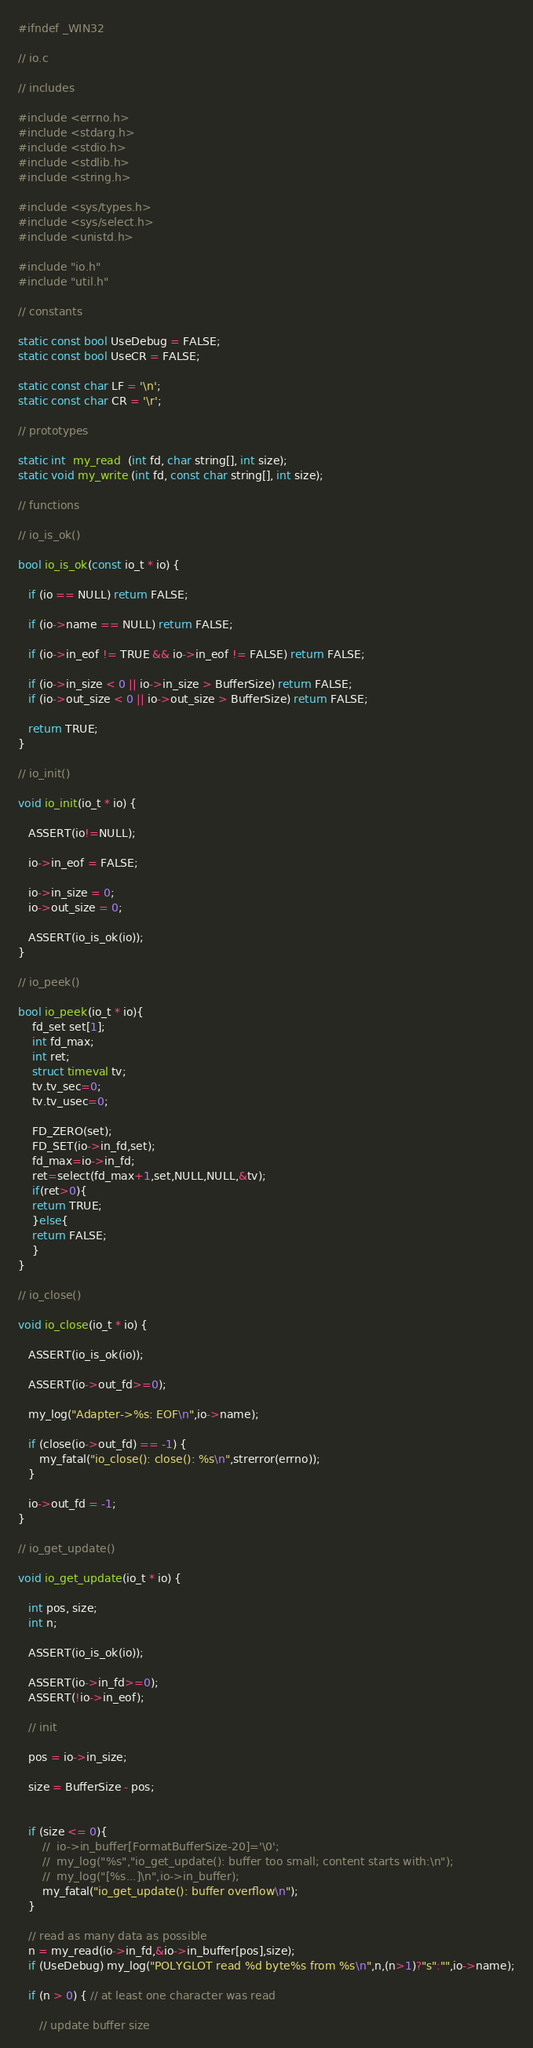Convert code to text. <code><loc_0><loc_0><loc_500><loc_500><_C_>#ifndef _WIN32

// io.c

// includes

#include <errno.h>
#include <stdarg.h>
#include <stdio.h>
#include <stdlib.h>
#include <string.h>

#include <sys/types.h>
#include <sys/select.h>
#include <unistd.h>

#include "io.h"
#include "util.h"

// constants

static const bool UseDebug = FALSE;
static const bool UseCR = FALSE;

static const char LF = '\n';
static const char CR = '\r';

// prototypes

static int  my_read  (int fd, char string[], int size);
static void my_write (int fd, const char string[], int size);

// functions

// io_is_ok()

bool io_is_ok(const io_t * io) {

   if (io == NULL) return FALSE;

   if (io->name == NULL) return FALSE;

   if (io->in_eof != TRUE && io->in_eof != FALSE) return FALSE;

   if (io->in_size < 0 || io->in_size > BufferSize) return FALSE;
   if (io->out_size < 0 || io->out_size > BufferSize) return FALSE;

   return TRUE;
}

// io_init()

void io_init(io_t * io) {

   ASSERT(io!=NULL);

   io->in_eof = FALSE;

   io->in_size = 0;
   io->out_size = 0;

   ASSERT(io_is_ok(io));
}

// io_peek()

bool io_peek(io_t * io){
    fd_set set[1];
    int fd_max;
    int ret;
    struct timeval tv;
    tv.tv_sec=0;
    tv.tv_usec=0;
  
    FD_ZERO(set);
    FD_SET(io->in_fd,set);
    fd_max=io->in_fd;
    ret=select(fd_max+1,set,NULL,NULL,&tv);
    if(ret>0){
	return TRUE;
    }else{
	return FALSE;
    }
}

// io_close()

void io_close(io_t * io) {

   ASSERT(io_is_ok(io));

   ASSERT(io->out_fd>=0);

   my_log("Adapter->%s: EOF\n",io->name);

   if (close(io->out_fd) == -1) {
      my_fatal("io_close(): close(): %s\n",strerror(errno));
   }

   io->out_fd = -1;
}

// io_get_update()

void io_get_update(io_t * io) {

   int pos, size;
   int n;

   ASSERT(io_is_ok(io));

   ASSERT(io->in_fd>=0);
   ASSERT(!io->in_eof);

   // init

   pos = io->in_size;

   size = BufferSize - pos;


   if (size <= 0){
       //  io->in_buffer[FormatBufferSize-20]='\0';
       //  my_log("%s","io_get_update(): buffer too small; content starts with:\n");
       //  my_log("[%s...]\n",io->in_buffer);
       my_fatal("io_get_update(): buffer overflow\n");
   }

   // read as many data as possible
   n = my_read(io->in_fd,&io->in_buffer[pos],size);
   if (UseDebug) my_log("POLYGLOT read %d byte%s from %s\n",n,(n>1)?"s":"",io->name);

   if (n > 0) { // at least one character was read

      // update buffer size
</code> 